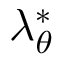Convert formula to latex. <formula><loc_0><loc_0><loc_500><loc_500>\lambda _ { \theta } ^ { * }</formula> 